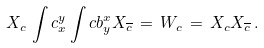Convert formula to latex. <formula><loc_0><loc_0><loc_500><loc_500>X _ { c } \, \int c _ { x } ^ { y } \int c b _ { y } ^ { x } X _ { \overline { c } } \, = \, W _ { c } \, = \, X _ { c } X _ { \overline { c } } \, .</formula> 